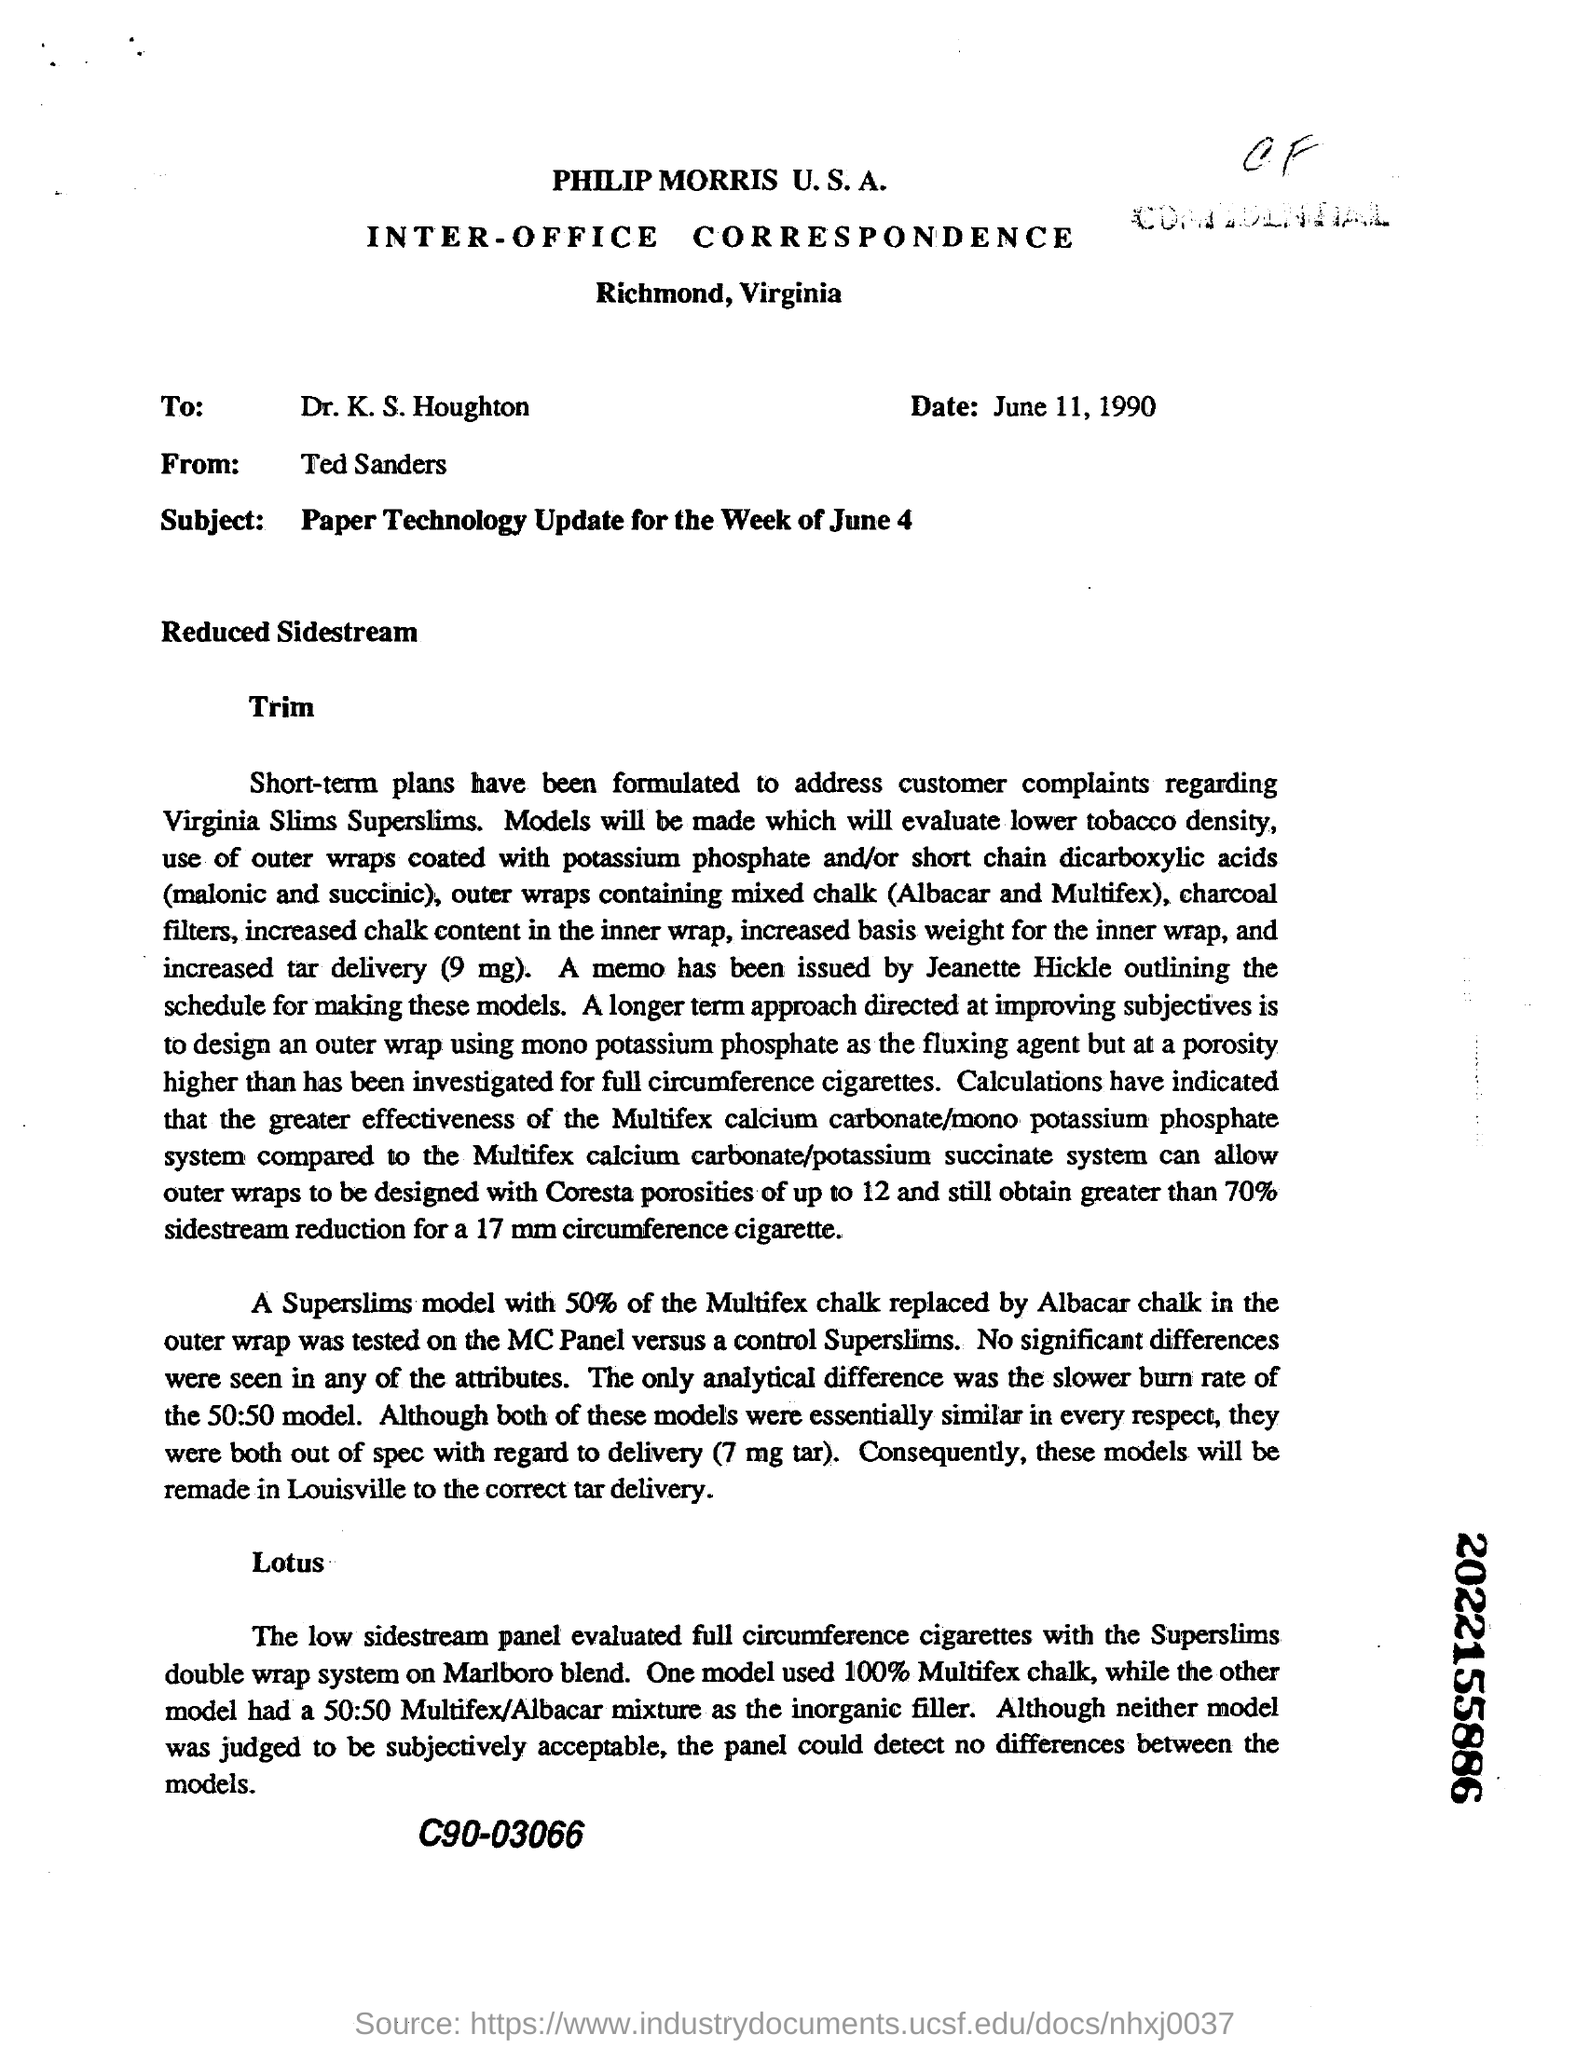What is the date in the letter
Ensure brevity in your answer.  June 11,1990. To whom this is addressed
Your response must be concise. Dr.K.S.Houghton. Who sent the letter?
Your answer should be very brief. Ted Sanders. Which part of Virginia is this letter sent from
Your answer should be compact. Richmond. 